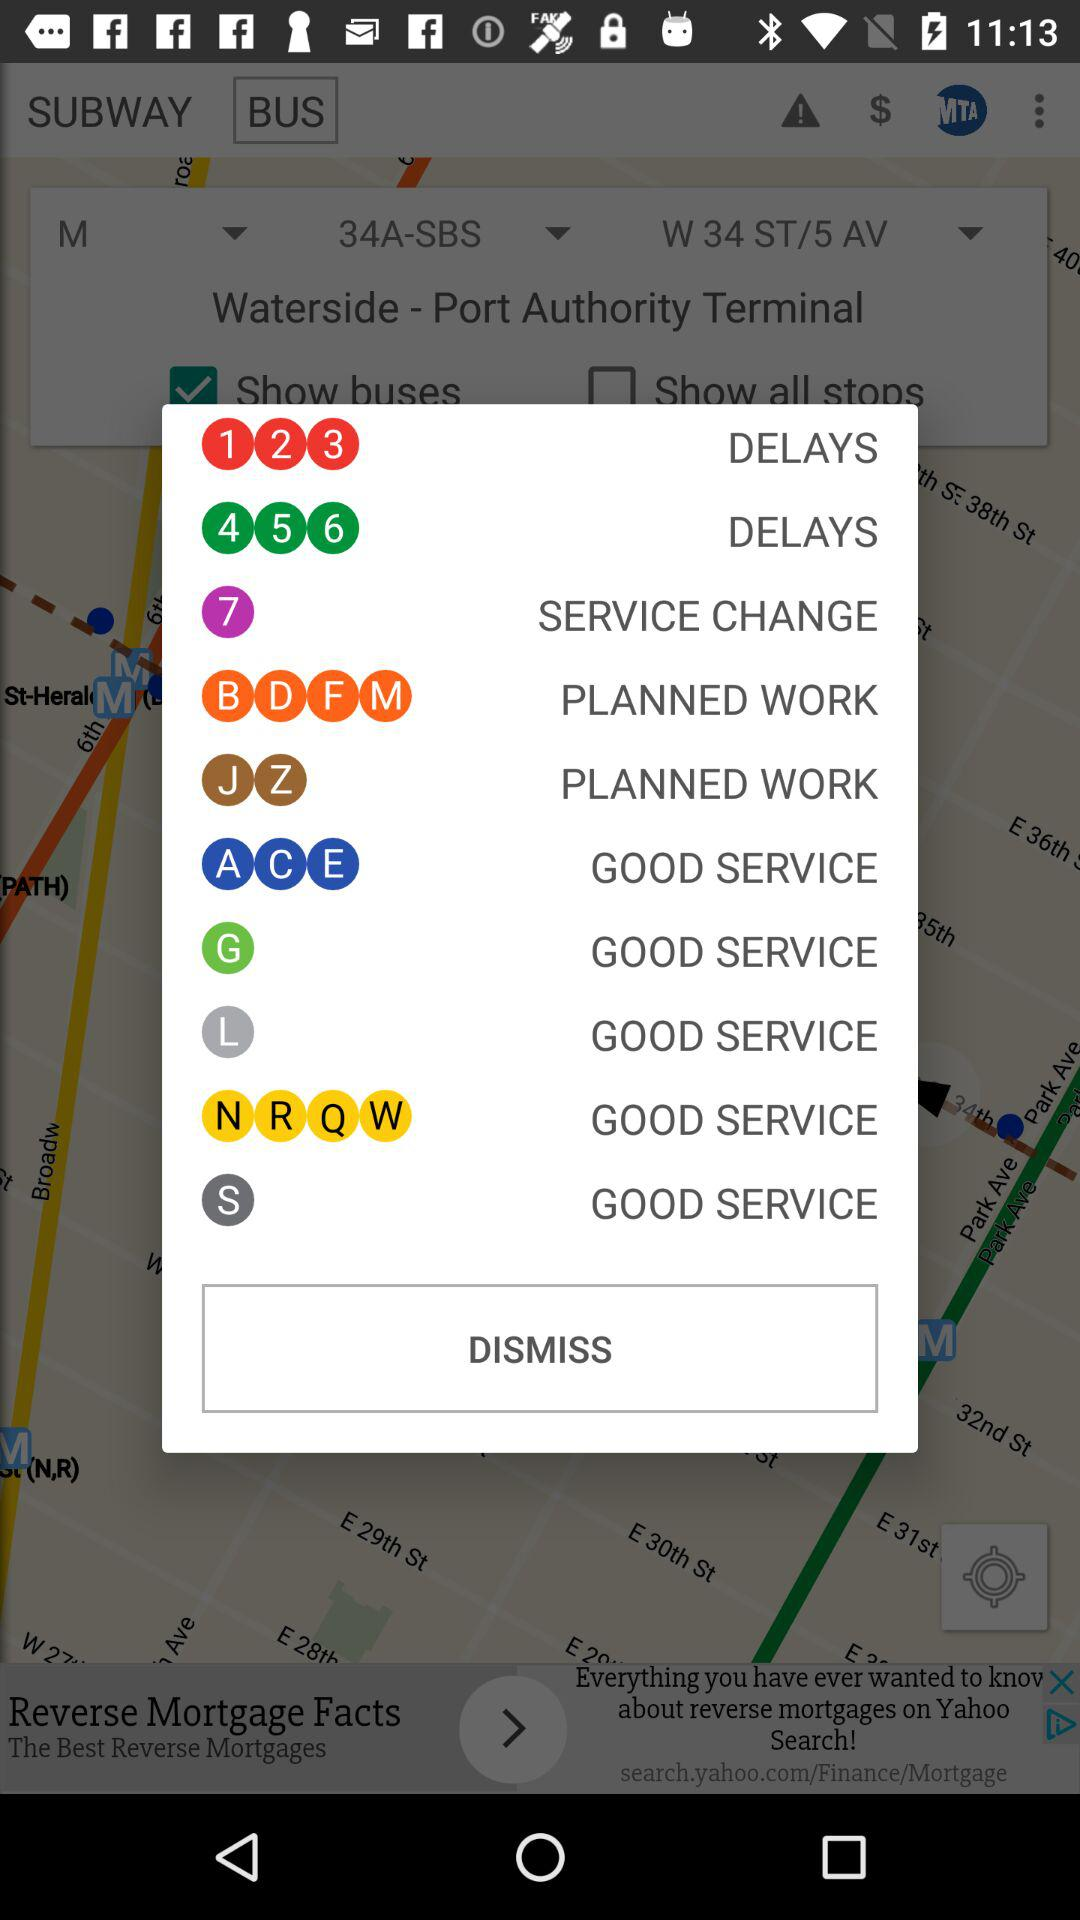How many items have the text 'GOOD SERVICE'?
Answer the question using a single word or phrase. 5 